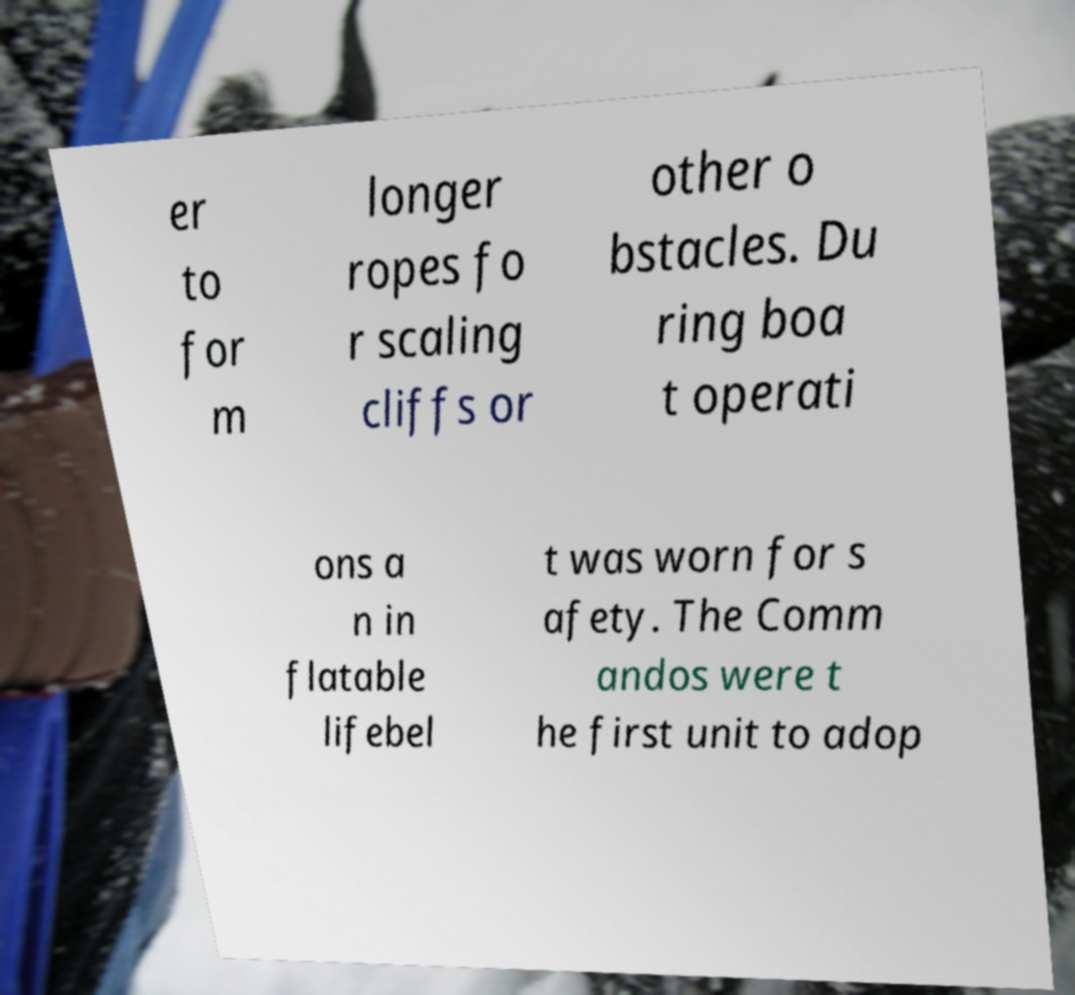Can you read and provide the text displayed in the image?This photo seems to have some interesting text. Can you extract and type it out for me? er to for m longer ropes fo r scaling cliffs or other o bstacles. Du ring boa t operati ons a n in flatable lifebel t was worn for s afety. The Comm andos were t he first unit to adop 